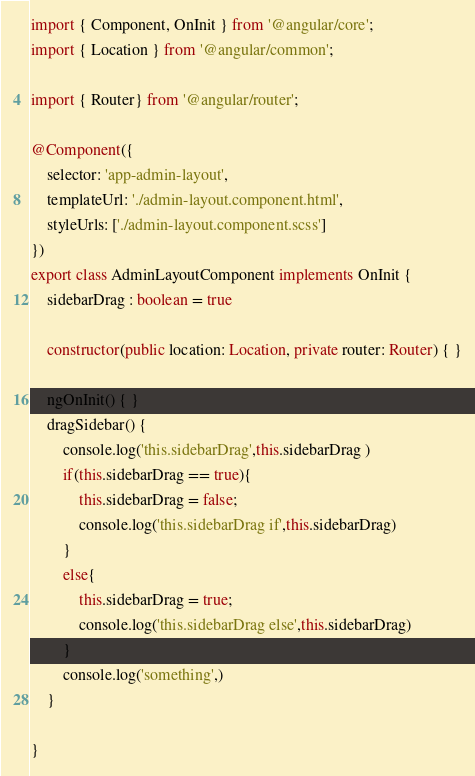Convert code to text. <code><loc_0><loc_0><loc_500><loc_500><_TypeScript_>import { Component, OnInit } from '@angular/core';
import { Location } from '@angular/common';

import { Router} from '@angular/router';

@Component({
    selector: 'app-admin-layout',
    templateUrl: './admin-layout.component.html',
    styleUrls: ['./admin-layout.component.scss']
})
export class AdminLayoutComponent implements OnInit {
    sidebarDrag : boolean = true

    constructor(public location: Location, private router: Router) { }

    ngOnInit() { }
    dragSidebar() {
        console.log('this.sidebarDrag',this.sidebarDrag )
        if(this.sidebarDrag == true){
            this.sidebarDrag = false;
            console.log('this.sidebarDrag if',this.sidebarDrag)
        }
        else{
            this.sidebarDrag = true;
            console.log('this.sidebarDrag else',this.sidebarDrag)
        }
        console.log('something',)
    }

}
</code> 